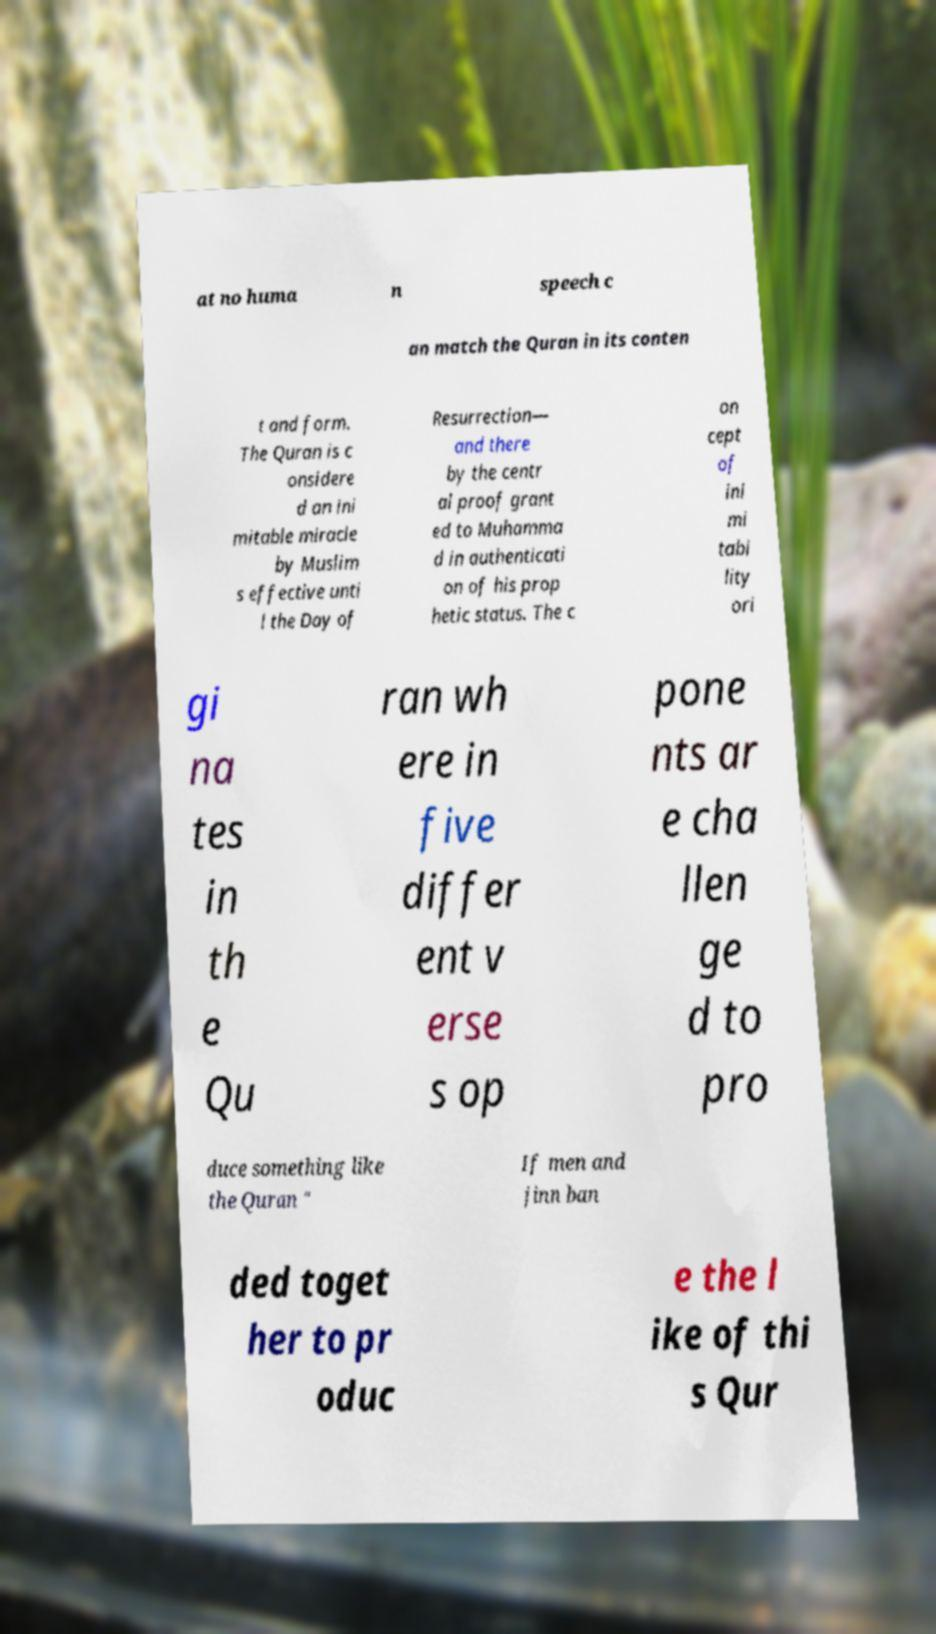Could you extract and type out the text from this image? at no huma n speech c an match the Quran in its conten t and form. The Quran is c onsidere d an ini mitable miracle by Muslim s effective unti l the Day of Resurrection— and there by the centr al proof grant ed to Muhamma d in authenticati on of his prop hetic status. The c on cept of ini mi tabi lity ori gi na tes in th e Qu ran wh ere in five differ ent v erse s op pone nts ar e cha llen ge d to pro duce something like the Quran " If men and jinn ban ded toget her to pr oduc e the l ike of thi s Qur 